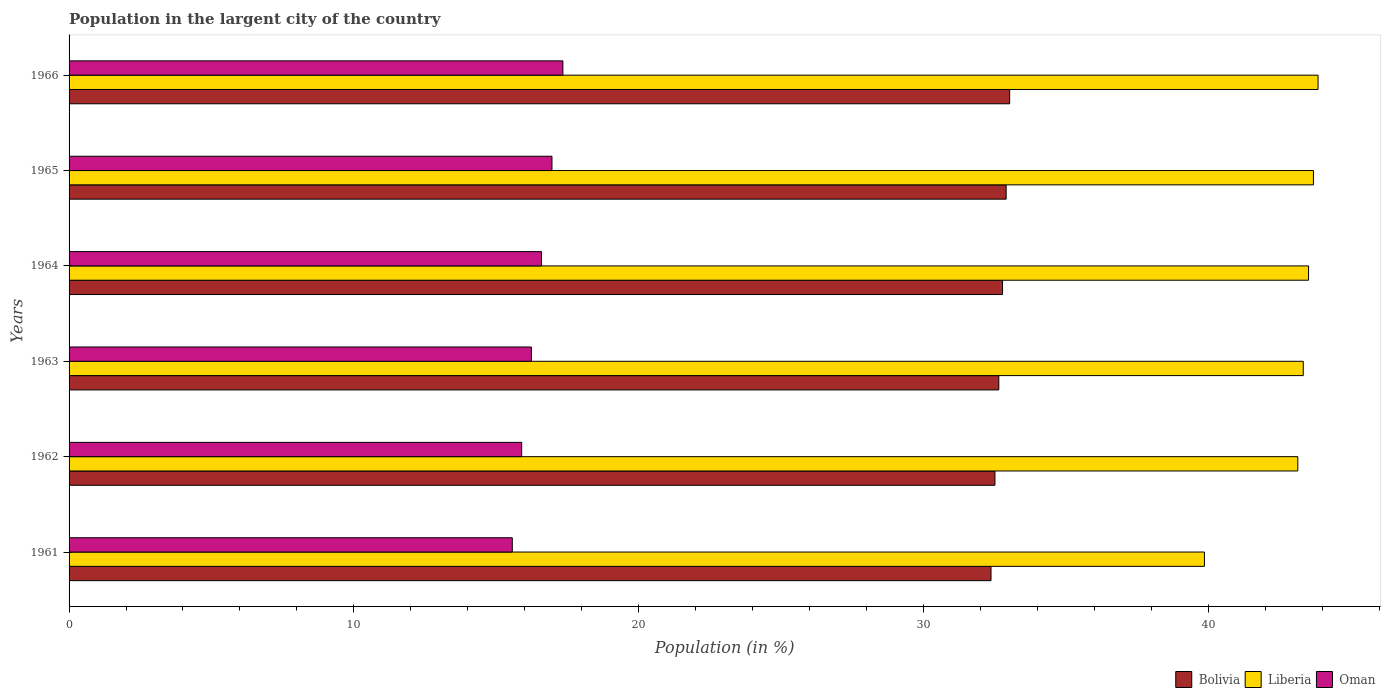How many different coloured bars are there?
Your answer should be compact. 3. Are the number of bars per tick equal to the number of legend labels?
Ensure brevity in your answer.  Yes. Are the number of bars on each tick of the Y-axis equal?
Give a very brief answer. Yes. What is the label of the 2nd group of bars from the top?
Keep it short and to the point. 1965. In how many cases, is the number of bars for a given year not equal to the number of legend labels?
Provide a succinct answer. 0. What is the percentage of population in the largent city in Liberia in 1966?
Your answer should be very brief. 43.86. Across all years, what is the maximum percentage of population in the largent city in Bolivia?
Provide a succinct answer. 33.03. Across all years, what is the minimum percentage of population in the largent city in Liberia?
Offer a terse response. 39.87. In which year was the percentage of population in the largent city in Bolivia maximum?
Keep it short and to the point. 1966. In which year was the percentage of population in the largent city in Oman minimum?
Provide a succinct answer. 1961. What is the total percentage of population in the largent city in Bolivia in the graph?
Your answer should be very brief. 196.25. What is the difference between the percentage of population in the largent city in Oman in 1964 and that in 1965?
Keep it short and to the point. -0.37. What is the difference between the percentage of population in the largent city in Liberia in 1966 and the percentage of population in the largent city in Bolivia in 1961?
Provide a short and direct response. 11.48. What is the average percentage of population in the largent city in Liberia per year?
Make the answer very short. 42.91. In the year 1961, what is the difference between the percentage of population in the largent city in Bolivia and percentage of population in the largent city in Liberia?
Give a very brief answer. -7.49. In how many years, is the percentage of population in the largent city in Bolivia greater than 20 %?
Keep it short and to the point. 6. What is the ratio of the percentage of population in the largent city in Bolivia in 1964 to that in 1966?
Your answer should be compact. 0.99. Is the percentage of population in the largent city in Bolivia in 1961 less than that in 1962?
Provide a short and direct response. Yes. What is the difference between the highest and the second highest percentage of population in the largent city in Liberia?
Your answer should be very brief. 0.16. What is the difference between the highest and the lowest percentage of population in the largent city in Bolivia?
Provide a succinct answer. 0.65. In how many years, is the percentage of population in the largent city in Bolivia greater than the average percentage of population in the largent city in Bolivia taken over all years?
Offer a very short reply. 3. What does the 2nd bar from the bottom in 1964 represents?
Offer a terse response. Liberia. Is it the case that in every year, the sum of the percentage of population in the largent city in Oman and percentage of population in the largent city in Bolivia is greater than the percentage of population in the largent city in Liberia?
Make the answer very short. Yes. How many bars are there?
Your answer should be compact. 18. What is the difference between two consecutive major ticks on the X-axis?
Offer a terse response. 10. Does the graph contain any zero values?
Ensure brevity in your answer.  No. Does the graph contain grids?
Ensure brevity in your answer.  No. Where does the legend appear in the graph?
Give a very brief answer. Bottom right. How are the legend labels stacked?
Offer a terse response. Horizontal. What is the title of the graph?
Your response must be concise. Population in the largent city of the country. Does "Zimbabwe" appear as one of the legend labels in the graph?
Offer a very short reply. No. What is the label or title of the X-axis?
Your answer should be compact. Population (in %). What is the label or title of the Y-axis?
Keep it short and to the point. Years. What is the Population (in %) in Bolivia in 1961?
Your answer should be compact. 32.37. What is the Population (in %) of Liberia in 1961?
Your answer should be very brief. 39.87. What is the Population (in %) in Oman in 1961?
Provide a short and direct response. 15.56. What is the Population (in %) of Bolivia in 1962?
Your answer should be very brief. 32.51. What is the Population (in %) of Liberia in 1962?
Provide a short and direct response. 43.15. What is the Population (in %) of Oman in 1962?
Keep it short and to the point. 15.89. What is the Population (in %) of Bolivia in 1963?
Give a very brief answer. 32.65. What is the Population (in %) in Liberia in 1963?
Your answer should be compact. 43.34. What is the Population (in %) of Oman in 1963?
Your answer should be very brief. 16.23. What is the Population (in %) of Bolivia in 1964?
Your answer should be very brief. 32.78. What is the Population (in %) of Liberia in 1964?
Ensure brevity in your answer.  43.53. What is the Population (in %) in Oman in 1964?
Provide a succinct answer. 16.59. What is the Population (in %) in Bolivia in 1965?
Offer a very short reply. 32.91. What is the Population (in %) in Liberia in 1965?
Keep it short and to the point. 43.7. What is the Population (in %) of Oman in 1965?
Offer a very short reply. 16.96. What is the Population (in %) in Bolivia in 1966?
Provide a succinct answer. 33.03. What is the Population (in %) of Liberia in 1966?
Give a very brief answer. 43.86. What is the Population (in %) in Oman in 1966?
Ensure brevity in your answer.  17.34. Across all years, what is the maximum Population (in %) in Bolivia?
Provide a succinct answer. 33.03. Across all years, what is the maximum Population (in %) in Liberia?
Your response must be concise. 43.86. Across all years, what is the maximum Population (in %) of Oman?
Offer a terse response. 17.34. Across all years, what is the minimum Population (in %) of Bolivia?
Give a very brief answer. 32.37. Across all years, what is the minimum Population (in %) in Liberia?
Offer a terse response. 39.87. Across all years, what is the minimum Population (in %) in Oman?
Provide a short and direct response. 15.56. What is the total Population (in %) of Bolivia in the graph?
Your answer should be compact. 196.25. What is the total Population (in %) of Liberia in the graph?
Your answer should be compact. 257.44. What is the total Population (in %) in Oman in the graph?
Ensure brevity in your answer.  98.58. What is the difference between the Population (in %) of Bolivia in 1961 and that in 1962?
Your response must be concise. -0.14. What is the difference between the Population (in %) in Liberia in 1961 and that in 1962?
Ensure brevity in your answer.  -3.28. What is the difference between the Population (in %) of Oman in 1961 and that in 1962?
Your answer should be very brief. -0.33. What is the difference between the Population (in %) of Bolivia in 1961 and that in 1963?
Your answer should be very brief. -0.27. What is the difference between the Population (in %) of Liberia in 1961 and that in 1963?
Make the answer very short. -3.47. What is the difference between the Population (in %) in Oman in 1961 and that in 1963?
Your answer should be compact. -0.67. What is the difference between the Population (in %) in Bolivia in 1961 and that in 1964?
Provide a succinct answer. -0.41. What is the difference between the Population (in %) in Liberia in 1961 and that in 1964?
Give a very brief answer. -3.66. What is the difference between the Population (in %) of Oman in 1961 and that in 1964?
Your answer should be compact. -1.03. What is the difference between the Population (in %) of Bolivia in 1961 and that in 1965?
Give a very brief answer. -0.53. What is the difference between the Population (in %) of Liberia in 1961 and that in 1965?
Provide a succinct answer. -3.83. What is the difference between the Population (in %) of Oman in 1961 and that in 1965?
Make the answer very short. -1.39. What is the difference between the Population (in %) of Bolivia in 1961 and that in 1966?
Your response must be concise. -0.65. What is the difference between the Population (in %) of Liberia in 1961 and that in 1966?
Provide a short and direct response. -3.99. What is the difference between the Population (in %) of Oman in 1961 and that in 1966?
Your response must be concise. -1.78. What is the difference between the Population (in %) of Bolivia in 1962 and that in 1963?
Offer a very short reply. -0.14. What is the difference between the Population (in %) in Liberia in 1962 and that in 1963?
Your answer should be compact. -0.19. What is the difference between the Population (in %) of Oman in 1962 and that in 1963?
Keep it short and to the point. -0.34. What is the difference between the Population (in %) in Bolivia in 1962 and that in 1964?
Your answer should be compact. -0.27. What is the difference between the Population (in %) of Liberia in 1962 and that in 1964?
Your answer should be very brief. -0.38. What is the difference between the Population (in %) of Oman in 1962 and that in 1964?
Your response must be concise. -0.7. What is the difference between the Population (in %) of Bolivia in 1962 and that in 1965?
Your answer should be compact. -0.39. What is the difference between the Population (in %) of Liberia in 1962 and that in 1965?
Provide a short and direct response. -0.55. What is the difference between the Population (in %) in Oman in 1962 and that in 1965?
Offer a terse response. -1.06. What is the difference between the Population (in %) of Bolivia in 1962 and that in 1966?
Offer a terse response. -0.52. What is the difference between the Population (in %) of Liberia in 1962 and that in 1966?
Offer a terse response. -0.71. What is the difference between the Population (in %) in Oman in 1962 and that in 1966?
Provide a short and direct response. -1.45. What is the difference between the Population (in %) in Bolivia in 1963 and that in 1964?
Keep it short and to the point. -0.13. What is the difference between the Population (in %) in Liberia in 1963 and that in 1964?
Ensure brevity in your answer.  -0.19. What is the difference between the Population (in %) in Oman in 1963 and that in 1964?
Provide a short and direct response. -0.36. What is the difference between the Population (in %) in Bolivia in 1963 and that in 1965?
Provide a short and direct response. -0.26. What is the difference between the Population (in %) of Liberia in 1963 and that in 1965?
Ensure brevity in your answer.  -0.36. What is the difference between the Population (in %) of Oman in 1963 and that in 1965?
Provide a short and direct response. -0.72. What is the difference between the Population (in %) of Bolivia in 1963 and that in 1966?
Offer a very short reply. -0.38. What is the difference between the Population (in %) of Liberia in 1963 and that in 1966?
Your answer should be very brief. -0.52. What is the difference between the Population (in %) in Oman in 1963 and that in 1966?
Offer a very short reply. -1.11. What is the difference between the Population (in %) in Bolivia in 1964 and that in 1965?
Give a very brief answer. -0.13. What is the difference between the Population (in %) of Liberia in 1964 and that in 1965?
Give a very brief answer. -0.17. What is the difference between the Population (in %) in Oman in 1964 and that in 1965?
Provide a succinct answer. -0.37. What is the difference between the Population (in %) of Bolivia in 1964 and that in 1966?
Offer a very short reply. -0.25. What is the difference between the Population (in %) in Liberia in 1964 and that in 1966?
Make the answer very short. -0.33. What is the difference between the Population (in %) in Oman in 1964 and that in 1966?
Your answer should be compact. -0.75. What is the difference between the Population (in %) of Bolivia in 1965 and that in 1966?
Your answer should be compact. -0.12. What is the difference between the Population (in %) in Liberia in 1965 and that in 1966?
Your answer should be compact. -0.16. What is the difference between the Population (in %) in Oman in 1965 and that in 1966?
Offer a terse response. -0.38. What is the difference between the Population (in %) of Bolivia in 1961 and the Population (in %) of Liberia in 1962?
Your answer should be very brief. -10.77. What is the difference between the Population (in %) of Bolivia in 1961 and the Population (in %) of Oman in 1962?
Your answer should be compact. 16.48. What is the difference between the Population (in %) of Liberia in 1961 and the Population (in %) of Oman in 1962?
Your answer should be compact. 23.97. What is the difference between the Population (in %) in Bolivia in 1961 and the Population (in %) in Liberia in 1963?
Offer a very short reply. -10.97. What is the difference between the Population (in %) in Bolivia in 1961 and the Population (in %) in Oman in 1963?
Your answer should be very brief. 16.14. What is the difference between the Population (in %) in Liberia in 1961 and the Population (in %) in Oman in 1963?
Provide a short and direct response. 23.63. What is the difference between the Population (in %) of Bolivia in 1961 and the Population (in %) of Liberia in 1964?
Your answer should be compact. -11.15. What is the difference between the Population (in %) of Bolivia in 1961 and the Population (in %) of Oman in 1964?
Your response must be concise. 15.79. What is the difference between the Population (in %) of Liberia in 1961 and the Population (in %) of Oman in 1964?
Ensure brevity in your answer.  23.28. What is the difference between the Population (in %) of Bolivia in 1961 and the Population (in %) of Liberia in 1965?
Provide a short and direct response. -11.32. What is the difference between the Population (in %) in Bolivia in 1961 and the Population (in %) in Oman in 1965?
Make the answer very short. 15.42. What is the difference between the Population (in %) in Liberia in 1961 and the Population (in %) in Oman in 1965?
Give a very brief answer. 22.91. What is the difference between the Population (in %) of Bolivia in 1961 and the Population (in %) of Liberia in 1966?
Offer a very short reply. -11.48. What is the difference between the Population (in %) of Bolivia in 1961 and the Population (in %) of Oman in 1966?
Make the answer very short. 15.03. What is the difference between the Population (in %) of Liberia in 1961 and the Population (in %) of Oman in 1966?
Offer a very short reply. 22.53. What is the difference between the Population (in %) of Bolivia in 1962 and the Population (in %) of Liberia in 1963?
Ensure brevity in your answer.  -10.83. What is the difference between the Population (in %) of Bolivia in 1962 and the Population (in %) of Oman in 1963?
Offer a terse response. 16.28. What is the difference between the Population (in %) in Liberia in 1962 and the Population (in %) in Oman in 1963?
Ensure brevity in your answer.  26.91. What is the difference between the Population (in %) in Bolivia in 1962 and the Population (in %) in Liberia in 1964?
Offer a very short reply. -11.01. What is the difference between the Population (in %) of Bolivia in 1962 and the Population (in %) of Oman in 1964?
Offer a terse response. 15.92. What is the difference between the Population (in %) in Liberia in 1962 and the Population (in %) in Oman in 1964?
Your answer should be compact. 26.56. What is the difference between the Population (in %) in Bolivia in 1962 and the Population (in %) in Liberia in 1965?
Your answer should be compact. -11.18. What is the difference between the Population (in %) of Bolivia in 1962 and the Population (in %) of Oman in 1965?
Provide a succinct answer. 15.56. What is the difference between the Population (in %) in Liberia in 1962 and the Population (in %) in Oman in 1965?
Provide a succinct answer. 26.19. What is the difference between the Population (in %) in Bolivia in 1962 and the Population (in %) in Liberia in 1966?
Give a very brief answer. -11.35. What is the difference between the Population (in %) in Bolivia in 1962 and the Population (in %) in Oman in 1966?
Keep it short and to the point. 15.17. What is the difference between the Population (in %) in Liberia in 1962 and the Population (in %) in Oman in 1966?
Ensure brevity in your answer.  25.81. What is the difference between the Population (in %) of Bolivia in 1963 and the Population (in %) of Liberia in 1964?
Offer a terse response. -10.88. What is the difference between the Population (in %) of Bolivia in 1963 and the Population (in %) of Oman in 1964?
Your answer should be compact. 16.06. What is the difference between the Population (in %) of Liberia in 1963 and the Population (in %) of Oman in 1964?
Offer a terse response. 26.75. What is the difference between the Population (in %) in Bolivia in 1963 and the Population (in %) in Liberia in 1965?
Keep it short and to the point. -11.05. What is the difference between the Population (in %) in Bolivia in 1963 and the Population (in %) in Oman in 1965?
Provide a succinct answer. 15.69. What is the difference between the Population (in %) in Liberia in 1963 and the Population (in %) in Oman in 1965?
Provide a succinct answer. 26.38. What is the difference between the Population (in %) of Bolivia in 1963 and the Population (in %) of Liberia in 1966?
Provide a succinct answer. -11.21. What is the difference between the Population (in %) of Bolivia in 1963 and the Population (in %) of Oman in 1966?
Your answer should be compact. 15.31. What is the difference between the Population (in %) in Liberia in 1963 and the Population (in %) in Oman in 1966?
Offer a very short reply. 26. What is the difference between the Population (in %) in Bolivia in 1964 and the Population (in %) in Liberia in 1965?
Provide a succinct answer. -10.92. What is the difference between the Population (in %) in Bolivia in 1964 and the Population (in %) in Oman in 1965?
Keep it short and to the point. 15.82. What is the difference between the Population (in %) of Liberia in 1964 and the Population (in %) of Oman in 1965?
Make the answer very short. 26.57. What is the difference between the Population (in %) in Bolivia in 1964 and the Population (in %) in Liberia in 1966?
Ensure brevity in your answer.  -11.08. What is the difference between the Population (in %) in Bolivia in 1964 and the Population (in %) in Oman in 1966?
Offer a very short reply. 15.44. What is the difference between the Population (in %) of Liberia in 1964 and the Population (in %) of Oman in 1966?
Your answer should be compact. 26.19. What is the difference between the Population (in %) in Bolivia in 1965 and the Population (in %) in Liberia in 1966?
Provide a succinct answer. -10.95. What is the difference between the Population (in %) in Bolivia in 1965 and the Population (in %) in Oman in 1966?
Your response must be concise. 15.57. What is the difference between the Population (in %) in Liberia in 1965 and the Population (in %) in Oman in 1966?
Offer a terse response. 26.36. What is the average Population (in %) of Bolivia per year?
Keep it short and to the point. 32.71. What is the average Population (in %) of Liberia per year?
Ensure brevity in your answer.  42.91. What is the average Population (in %) of Oman per year?
Your response must be concise. 16.43. In the year 1961, what is the difference between the Population (in %) of Bolivia and Population (in %) of Liberia?
Offer a terse response. -7.49. In the year 1961, what is the difference between the Population (in %) of Bolivia and Population (in %) of Oman?
Keep it short and to the point. 16.81. In the year 1961, what is the difference between the Population (in %) of Liberia and Population (in %) of Oman?
Provide a short and direct response. 24.3. In the year 1962, what is the difference between the Population (in %) in Bolivia and Population (in %) in Liberia?
Make the answer very short. -10.64. In the year 1962, what is the difference between the Population (in %) in Bolivia and Population (in %) in Oman?
Make the answer very short. 16.62. In the year 1962, what is the difference between the Population (in %) in Liberia and Population (in %) in Oman?
Your answer should be very brief. 27.25. In the year 1963, what is the difference between the Population (in %) of Bolivia and Population (in %) of Liberia?
Your answer should be compact. -10.69. In the year 1963, what is the difference between the Population (in %) of Bolivia and Population (in %) of Oman?
Keep it short and to the point. 16.41. In the year 1963, what is the difference between the Population (in %) of Liberia and Population (in %) of Oman?
Offer a terse response. 27.11. In the year 1964, what is the difference between the Population (in %) of Bolivia and Population (in %) of Liberia?
Your answer should be compact. -10.75. In the year 1964, what is the difference between the Population (in %) of Bolivia and Population (in %) of Oman?
Your response must be concise. 16.19. In the year 1964, what is the difference between the Population (in %) of Liberia and Population (in %) of Oman?
Your answer should be compact. 26.94. In the year 1965, what is the difference between the Population (in %) of Bolivia and Population (in %) of Liberia?
Give a very brief answer. -10.79. In the year 1965, what is the difference between the Population (in %) in Bolivia and Population (in %) in Oman?
Keep it short and to the point. 15.95. In the year 1965, what is the difference between the Population (in %) in Liberia and Population (in %) in Oman?
Provide a succinct answer. 26.74. In the year 1966, what is the difference between the Population (in %) of Bolivia and Population (in %) of Liberia?
Ensure brevity in your answer.  -10.83. In the year 1966, what is the difference between the Population (in %) of Bolivia and Population (in %) of Oman?
Give a very brief answer. 15.69. In the year 1966, what is the difference between the Population (in %) in Liberia and Population (in %) in Oman?
Your answer should be very brief. 26.52. What is the ratio of the Population (in %) of Bolivia in 1961 to that in 1962?
Give a very brief answer. 1. What is the ratio of the Population (in %) in Liberia in 1961 to that in 1962?
Ensure brevity in your answer.  0.92. What is the ratio of the Population (in %) of Oman in 1961 to that in 1962?
Offer a very short reply. 0.98. What is the ratio of the Population (in %) in Bolivia in 1961 to that in 1963?
Ensure brevity in your answer.  0.99. What is the ratio of the Population (in %) of Liberia in 1961 to that in 1963?
Your response must be concise. 0.92. What is the ratio of the Population (in %) of Oman in 1961 to that in 1963?
Keep it short and to the point. 0.96. What is the ratio of the Population (in %) of Bolivia in 1961 to that in 1964?
Offer a terse response. 0.99. What is the ratio of the Population (in %) of Liberia in 1961 to that in 1964?
Make the answer very short. 0.92. What is the ratio of the Population (in %) in Oman in 1961 to that in 1964?
Offer a terse response. 0.94. What is the ratio of the Population (in %) in Bolivia in 1961 to that in 1965?
Offer a very short reply. 0.98. What is the ratio of the Population (in %) in Liberia in 1961 to that in 1965?
Offer a very short reply. 0.91. What is the ratio of the Population (in %) in Oman in 1961 to that in 1965?
Keep it short and to the point. 0.92. What is the ratio of the Population (in %) of Bolivia in 1961 to that in 1966?
Ensure brevity in your answer.  0.98. What is the ratio of the Population (in %) of Liberia in 1961 to that in 1966?
Ensure brevity in your answer.  0.91. What is the ratio of the Population (in %) of Oman in 1961 to that in 1966?
Your answer should be very brief. 0.9. What is the ratio of the Population (in %) in Bolivia in 1962 to that in 1963?
Provide a short and direct response. 1. What is the ratio of the Population (in %) of Liberia in 1962 to that in 1963?
Your answer should be compact. 1. What is the ratio of the Population (in %) in Oman in 1962 to that in 1964?
Offer a terse response. 0.96. What is the ratio of the Population (in %) in Bolivia in 1962 to that in 1965?
Offer a very short reply. 0.99. What is the ratio of the Population (in %) in Liberia in 1962 to that in 1965?
Keep it short and to the point. 0.99. What is the ratio of the Population (in %) in Oman in 1962 to that in 1965?
Provide a short and direct response. 0.94. What is the ratio of the Population (in %) in Bolivia in 1962 to that in 1966?
Ensure brevity in your answer.  0.98. What is the ratio of the Population (in %) of Liberia in 1962 to that in 1966?
Your answer should be very brief. 0.98. What is the ratio of the Population (in %) in Oman in 1962 to that in 1966?
Offer a very short reply. 0.92. What is the ratio of the Population (in %) of Bolivia in 1963 to that in 1964?
Your response must be concise. 1. What is the ratio of the Population (in %) of Liberia in 1963 to that in 1964?
Offer a very short reply. 1. What is the ratio of the Population (in %) of Oman in 1963 to that in 1964?
Offer a terse response. 0.98. What is the ratio of the Population (in %) in Liberia in 1963 to that in 1965?
Offer a terse response. 0.99. What is the ratio of the Population (in %) in Oman in 1963 to that in 1965?
Your answer should be very brief. 0.96. What is the ratio of the Population (in %) in Bolivia in 1963 to that in 1966?
Keep it short and to the point. 0.99. What is the ratio of the Population (in %) in Oman in 1963 to that in 1966?
Keep it short and to the point. 0.94. What is the ratio of the Population (in %) in Liberia in 1964 to that in 1965?
Your answer should be compact. 1. What is the ratio of the Population (in %) in Oman in 1964 to that in 1965?
Provide a succinct answer. 0.98. What is the ratio of the Population (in %) of Bolivia in 1964 to that in 1966?
Your response must be concise. 0.99. What is the ratio of the Population (in %) in Oman in 1964 to that in 1966?
Provide a succinct answer. 0.96. What is the ratio of the Population (in %) of Oman in 1965 to that in 1966?
Give a very brief answer. 0.98. What is the difference between the highest and the second highest Population (in %) of Bolivia?
Your answer should be compact. 0.12. What is the difference between the highest and the second highest Population (in %) in Liberia?
Offer a very short reply. 0.16. What is the difference between the highest and the second highest Population (in %) of Oman?
Offer a very short reply. 0.38. What is the difference between the highest and the lowest Population (in %) in Bolivia?
Keep it short and to the point. 0.65. What is the difference between the highest and the lowest Population (in %) of Liberia?
Ensure brevity in your answer.  3.99. What is the difference between the highest and the lowest Population (in %) of Oman?
Make the answer very short. 1.78. 